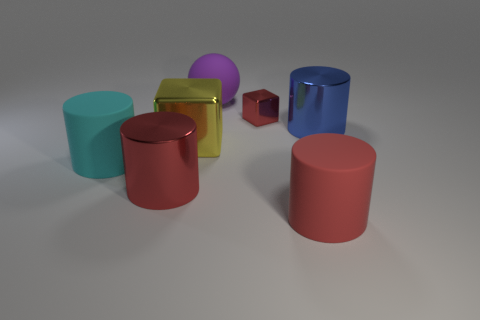If these objects were part of a collection, what might the theme of the collection be? If these objects were part of a collection, the theme could center around geometric exploration, showcasing various three-dimensional shapes and their properties, like volume, surface area, and symmetry. Furthermore, the collection could be highlighting the way light interacts with different material finishes, such as matte or glossy surfaces. 